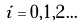<formula> <loc_0><loc_0><loc_500><loc_500>i = 0 , 1 , 2 \dots</formula> 